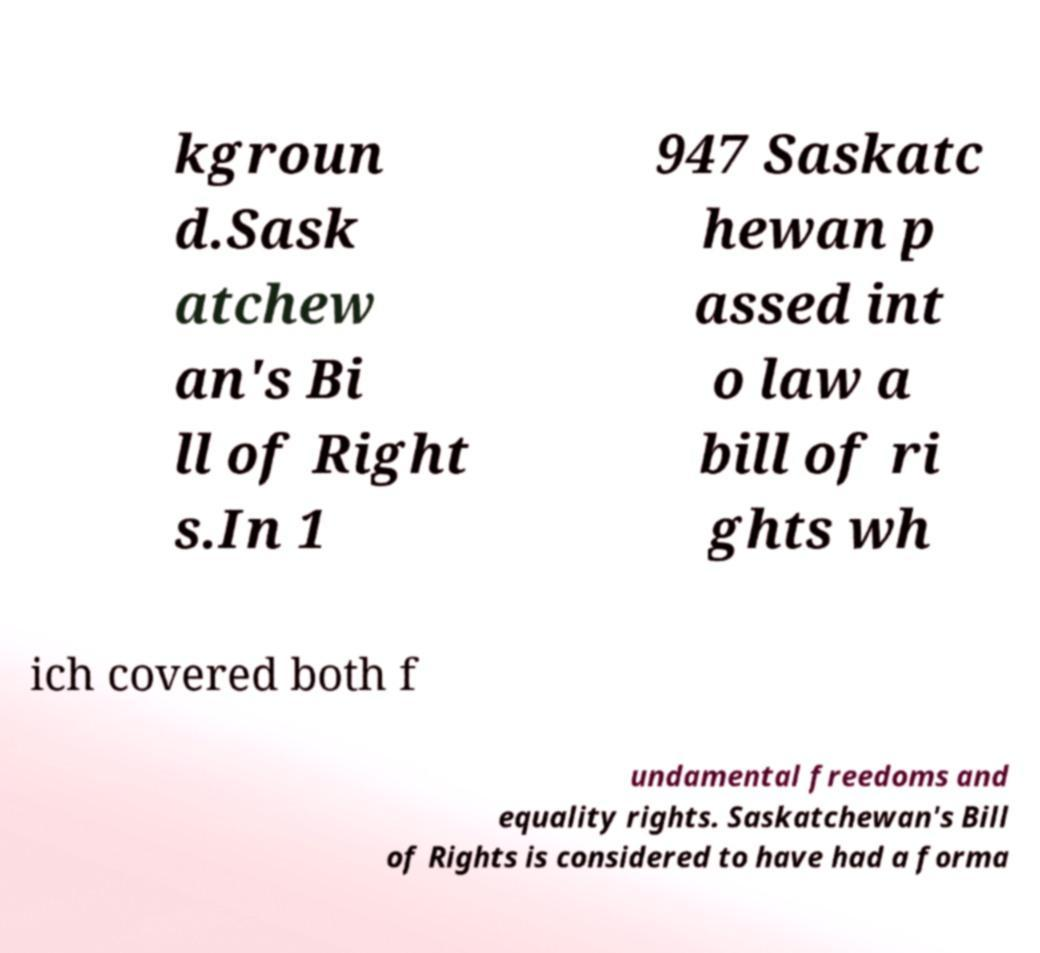For documentation purposes, I need the text within this image transcribed. Could you provide that? kgroun d.Sask atchew an's Bi ll of Right s.In 1 947 Saskatc hewan p assed int o law a bill of ri ghts wh ich covered both f undamental freedoms and equality rights. Saskatchewan's Bill of Rights is considered to have had a forma 